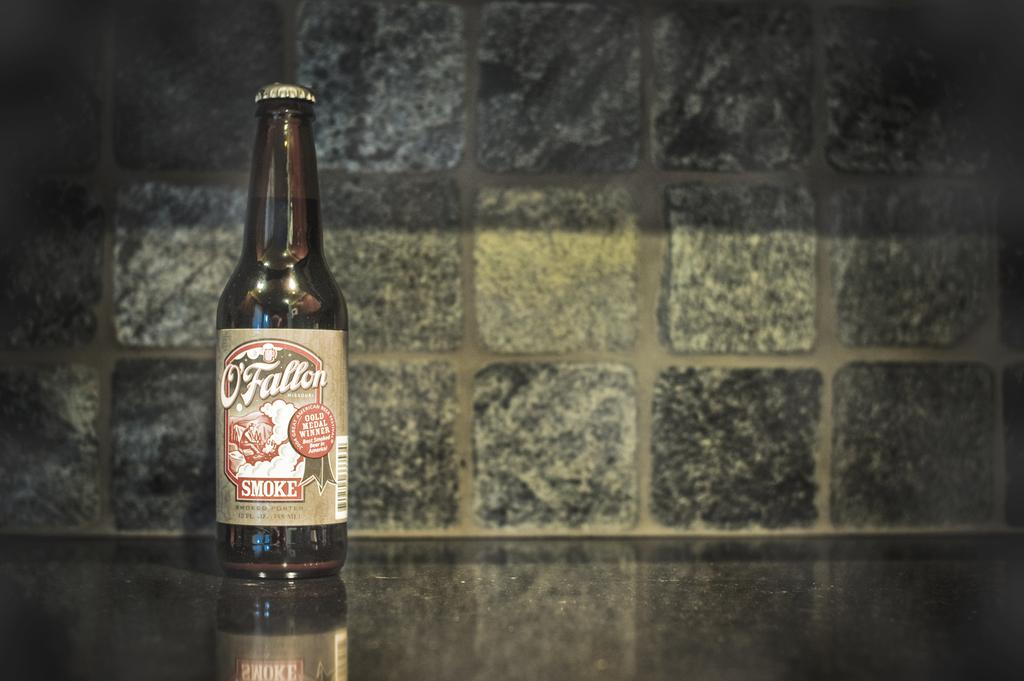<image>
Summarize the visual content of the image. An unopened bottle of O'fallon smoke ale sits on a worktop in front of some stone effect tiles by itself. 